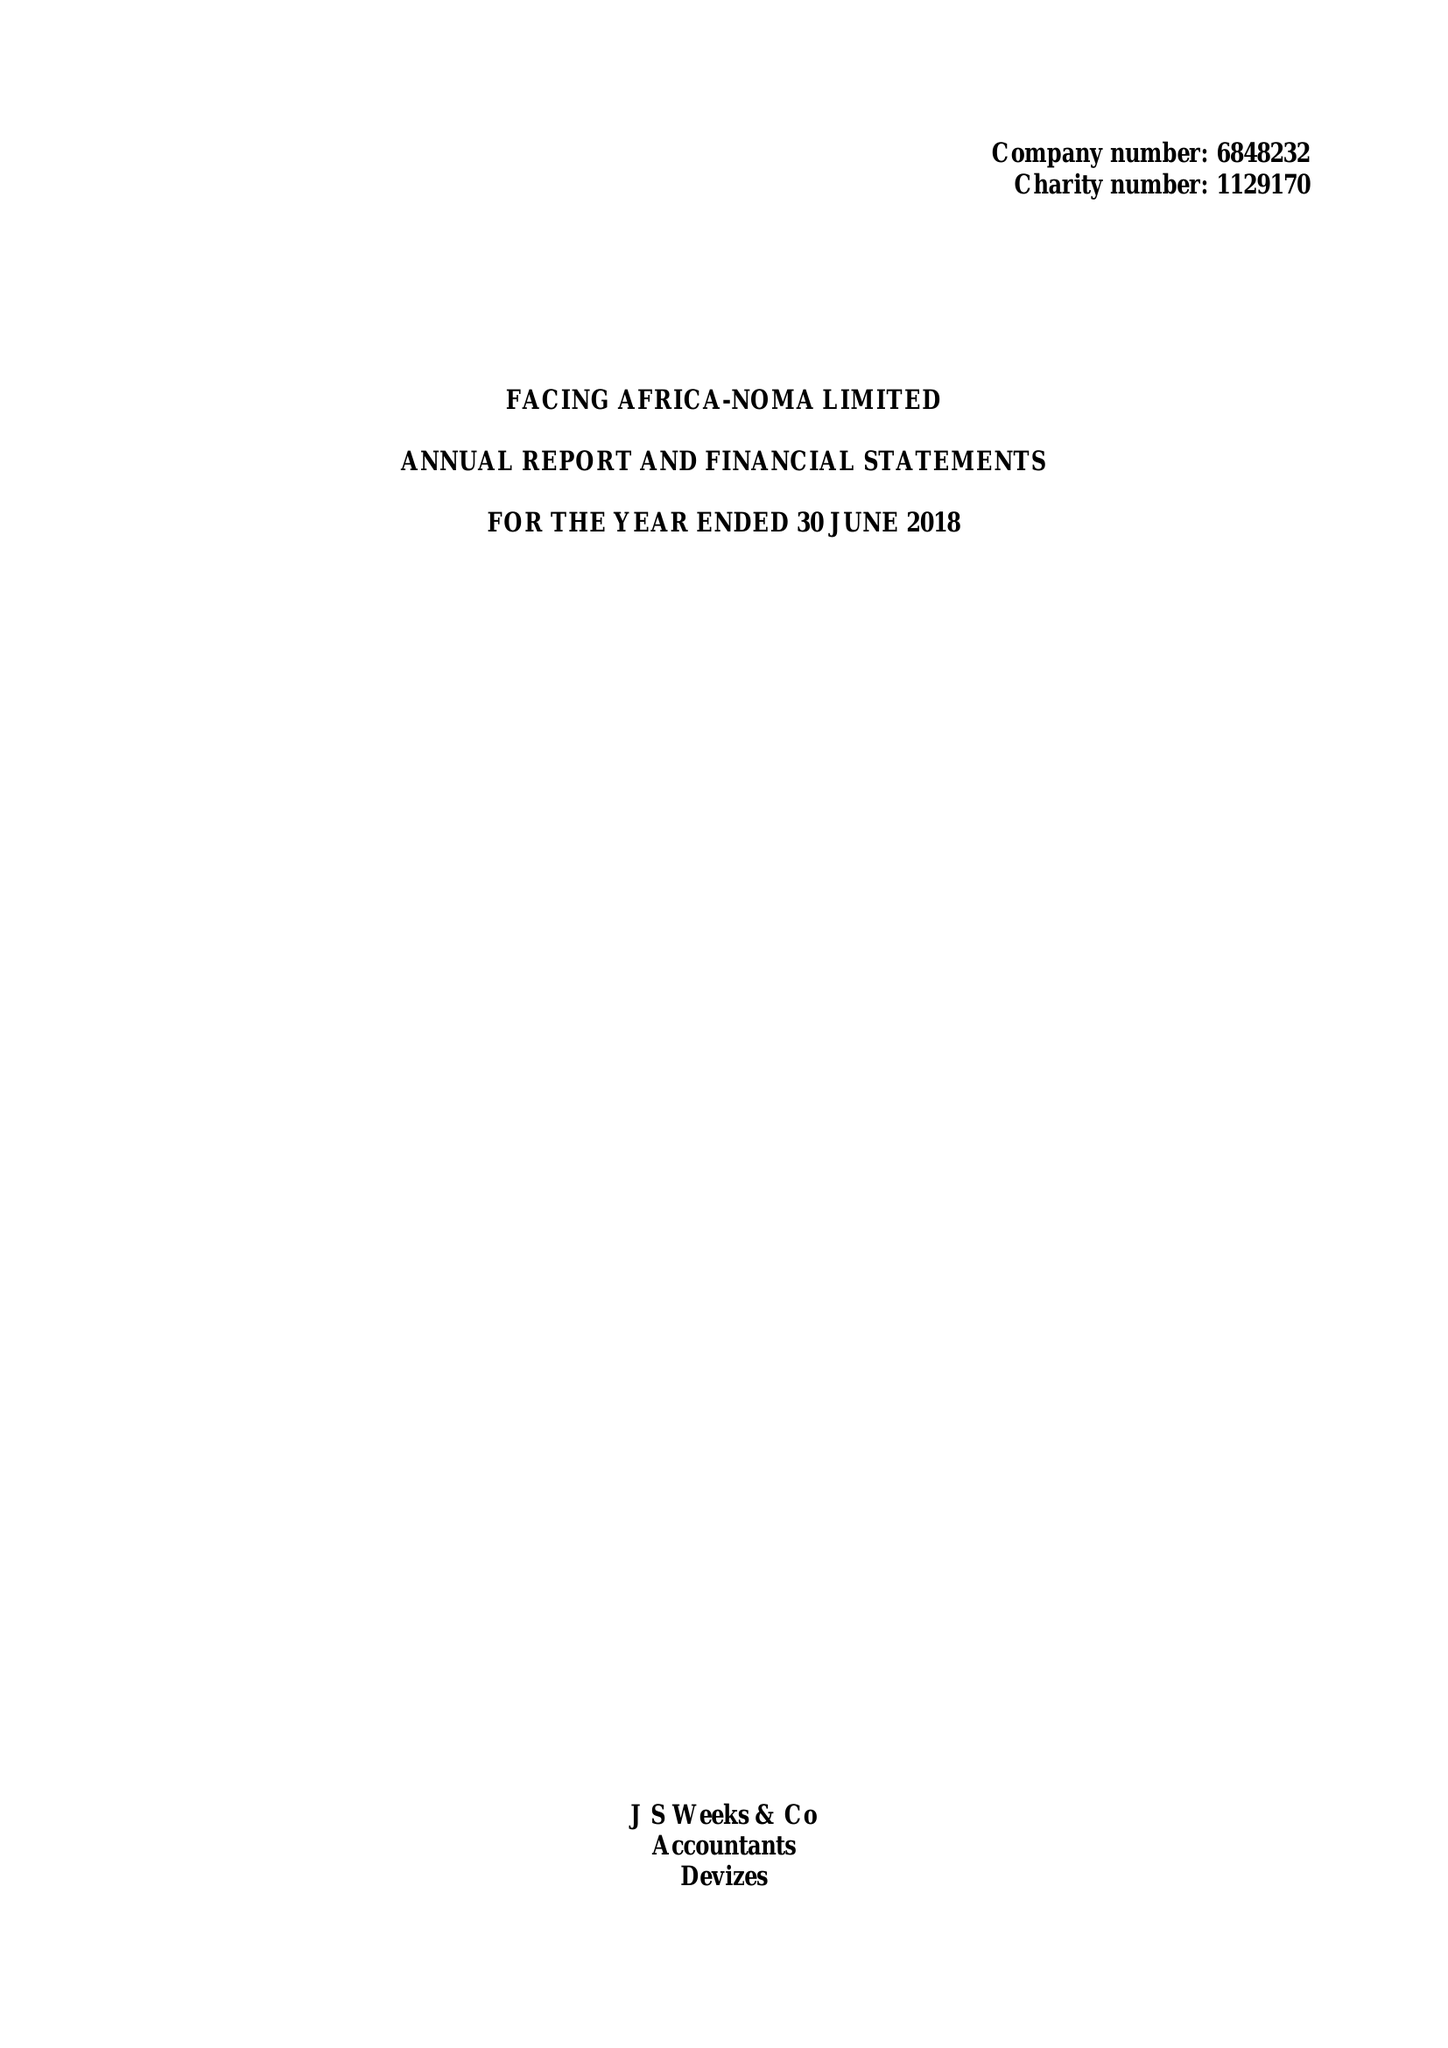What is the value for the charity_number?
Answer the question using a single word or phrase. 1129170 